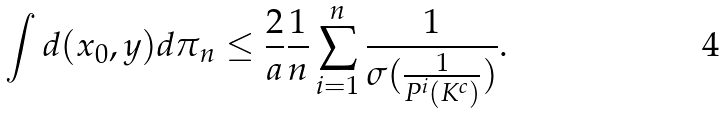Convert formula to latex. <formula><loc_0><loc_0><loc_500><loc_500>\int d ( x _ { 0 } , y ) d \pi _ { n } \leq \frac { 2 } { a } \frac { 1 } { n } \sum _ { i = 1 } ^ { n } \frac { 1 } { \sigma ( \frac { 1 } { P ^ { i } ( K ^ { c } ) } ) } .</formula> 